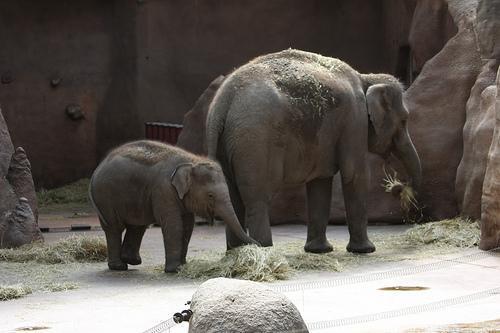How many elephants are there?
Give a very brief answer. 2. 